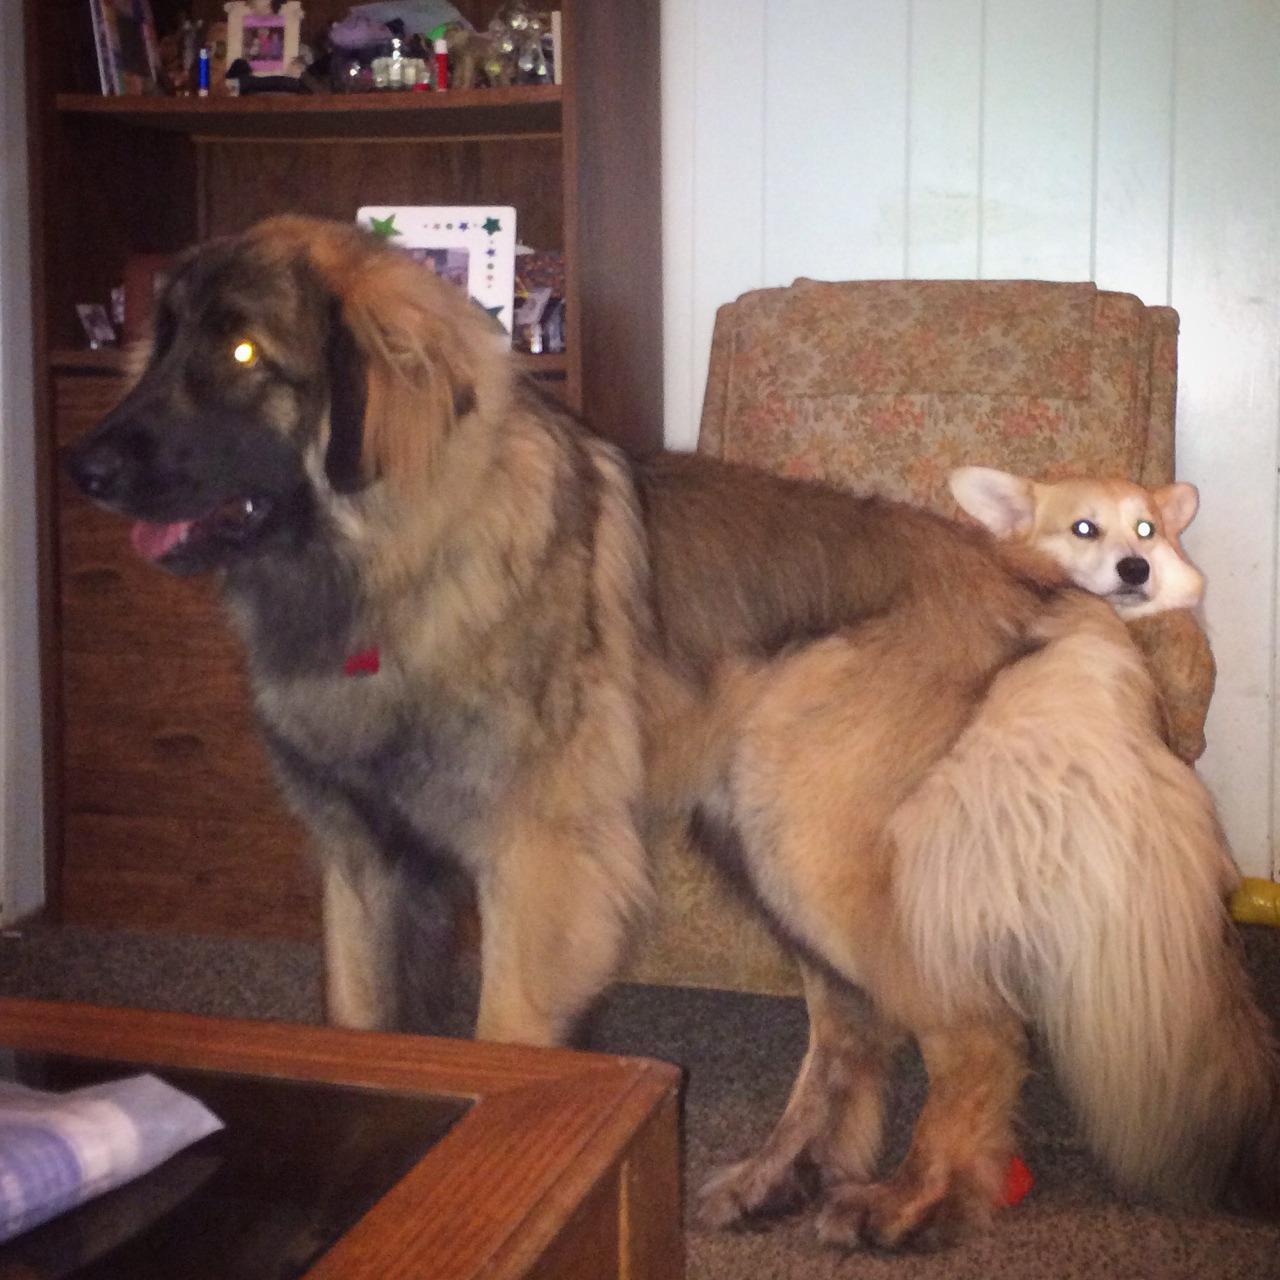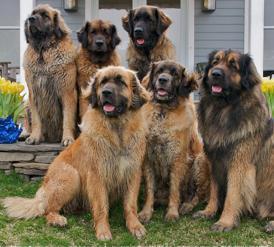The first image is the image on the left, the second image is the image on the right. Considering the images on both sides, is "One image is shot indoors with furniture and one image is outdoors with grass." valid? Answer yes or no. Yes. The first image is the image on the left, the second image is the image on the right. Considering the images on both sides, is "There are two dogs total." valid? Answer yes or no. No. 